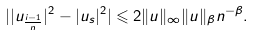<formula> <loc_0><loc_0><loc_500><loc_500>| | u _ { \frac { i - 1 } { n } } | ^ { 2 } - | u _ { s } | ^ { 2 } | \leqslant 2 \| u \| _ { \infty } \| u \| _ { \beta } n ^ { - \beta } .</formula> 